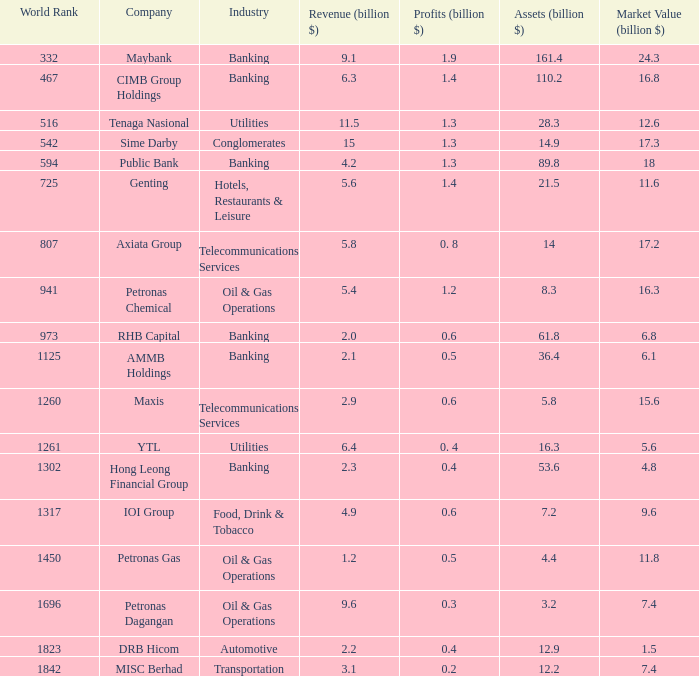Specify the international rank for market value 1 807.0. 